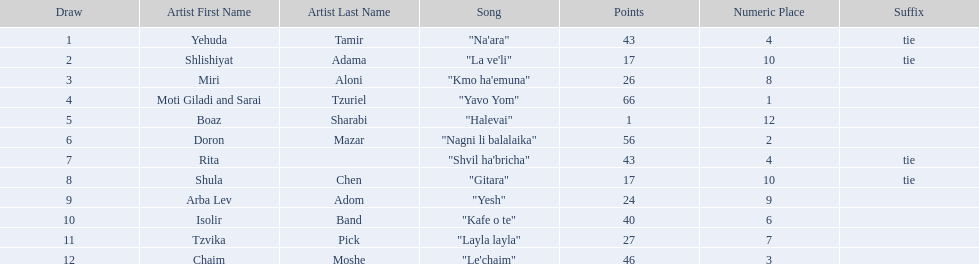What artist received the least amount of points in the competition? Boaz Sharabi. 